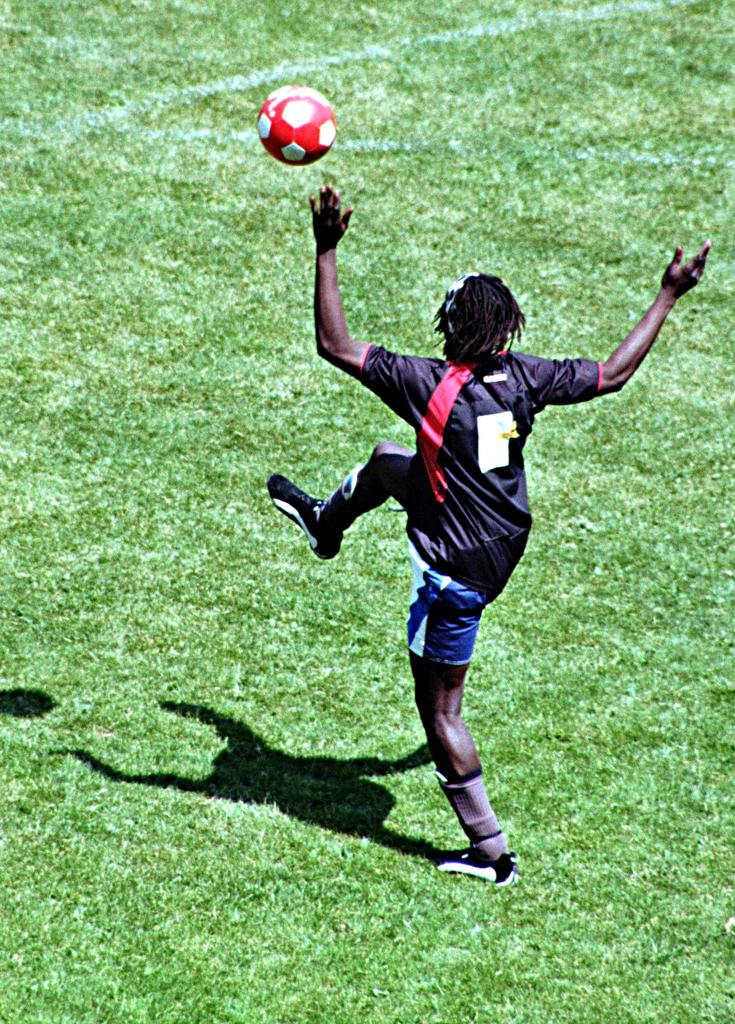Who is the main subject in the image? There is a man in the image. What is the man doing in the image? The man is playing football. What type of surface is the man playing on? There is grass on the ground in the image. What is the ball's position in the image? There is a ball in the air in the image. What color is the sweater the beast is wearing in the image? There is no beast or sweater present in the image. What is the man's afterthought while playing football in the image? The image does not provide information about the man's thoughts or afterthoughts while playing football. 